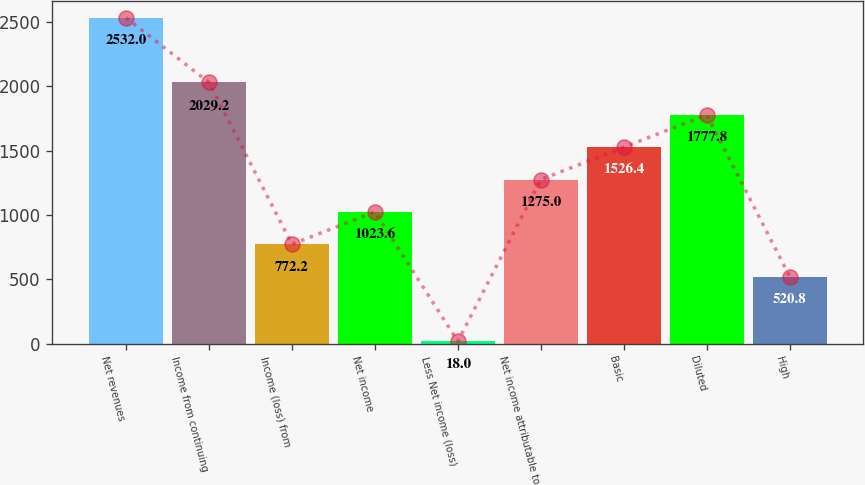Convert chart to OTSL. <chart><loc_0><loc_0><loc_500><loc_500><bar_chart><fcel>Net revenues<fcel>Income from continuing<fcel>Income (loss) from<fcel>Net income<fcel>Less Net income (loss)<fcel>Net income attributable to<fcel>Basic<fcel>Diluted<fcel>High<nl><fcel>2532<fcel>2029.2<fcel>772.2<fcel>1023.6<fcel>18<fcel>1275<fcel>1526.4<fcel>1777.8<fcel>520.8<nl></chart> 